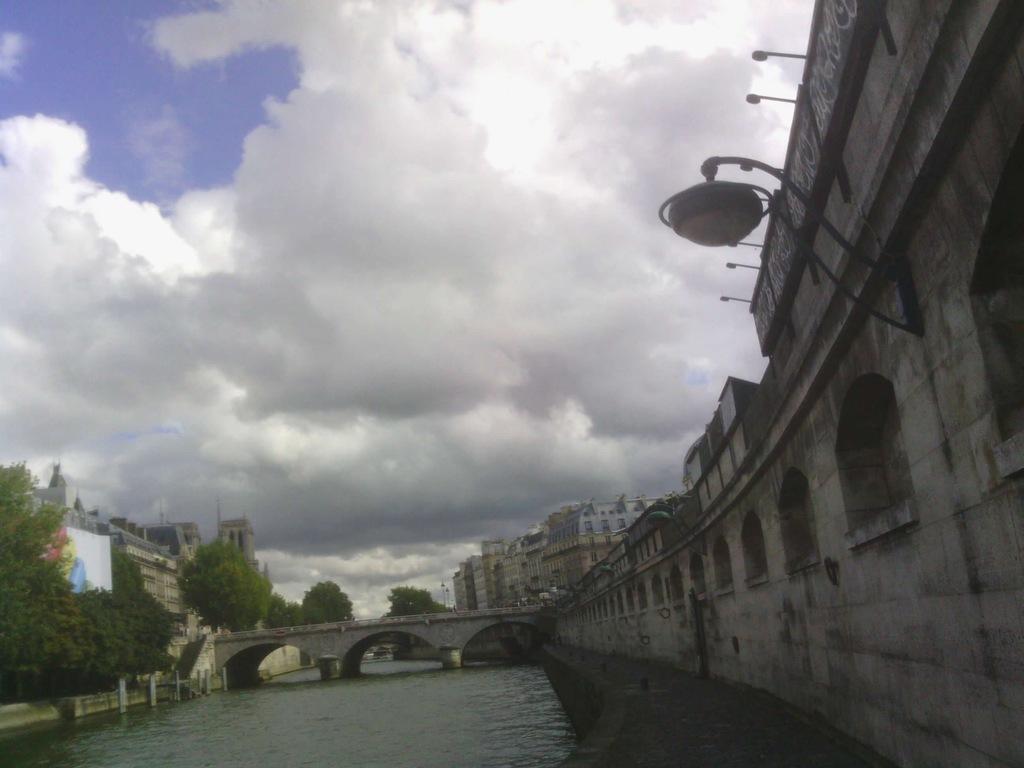Please provide a concise description of this image. In the image there is a river and on the river there is bridge and there is a wall on the right side, around the river there are many trees and buildings. 